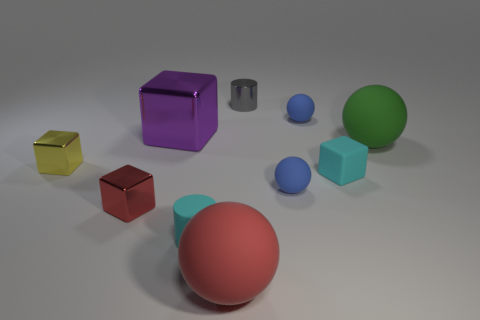Subtract all green balls. How many balls are left? 3 Subtract 2 spheres. How many spheres are left? 2 Subtract all green balls. How many balls are left? 3 Subtract all green cubes. How many blue spheres are left? 2 Subtract 0 green cylinders. How many objects are left? 10 Subtract all balls. How many objects are left? 6 Subtract all red spheres. Subtract all purple cubes. How many spheres are left? 3 Subtract all yellow metal cubes. Subtract all small red matte objects. How many objects are left? 9 Add 3 large green matte objects. How many large green matte objects are left? 4 Add 7 large shiny cylinders. How many large shiny cylinders exist? 7 